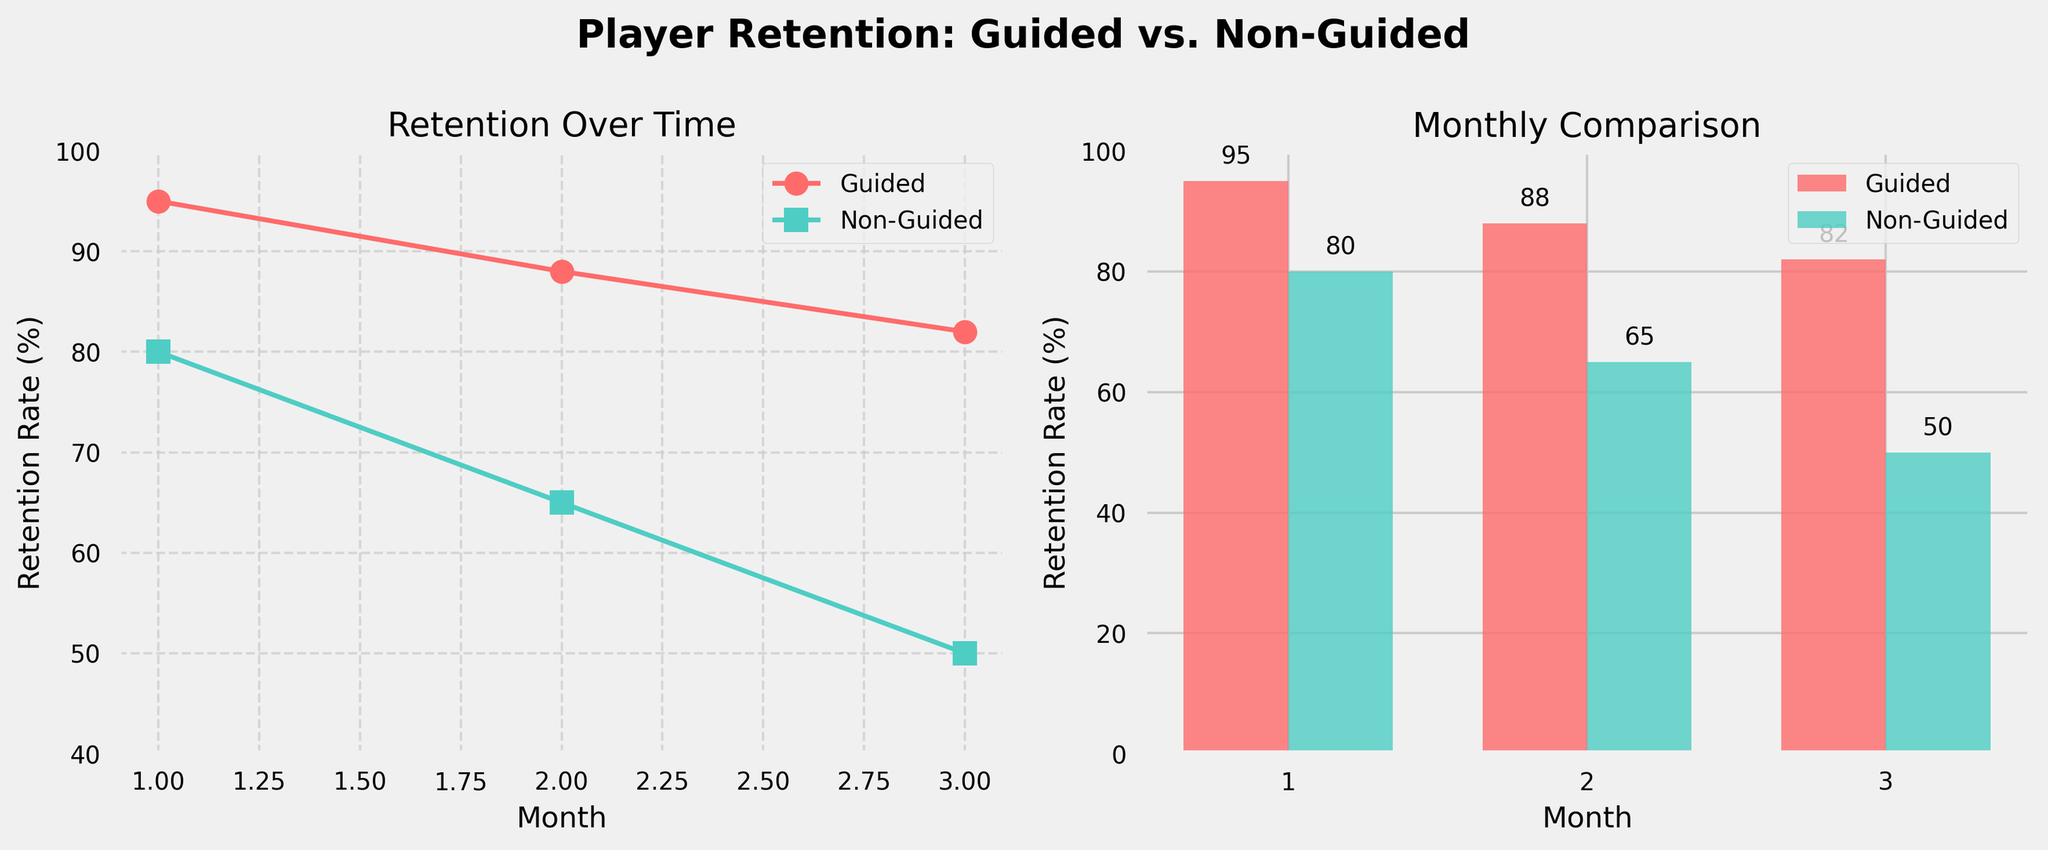What is the retention rate for guided players in the first month? Refer to the line plot or the bar chart, where the first-month retention rate for guided players is depicted.
Answer: 95% What is the title of the entire figure? The title is located at the top of the figure.
Answer: Player Retention: Guided vs. Non-Guided Which player group has a higher retention rate in the third month? Compare the retention rates for guided and non-guided players in the third month from either the line plot or bar chart.
Answer: Guided players By how much does the retention rate drop for non-guided players from the first to the second month? Subtract the retention rate in the second month from the retention rate in the first month for non-guided players (80% - 65%).
Answer: 15% What is the overall trend of retention rates for both guided and non-guided players over the three months? Examine the slopes of the lines in the line plot which show that retention rates decline for both groups over the three months.
Answer: Declining What are the colors used to represent guided and non-guided players in the plots? Identify the colors on the legends of the subplots. Guided players are represented with one color and non-guided players with another.
Answer: Red for guided, teal for non-guided How much higher is the retention rate for guided players compared to non-guided players in the second month? Subtract the non-guided players' retention rate from the guided players' retention rate in the second month (88% - 65%).
Answer: 23% By what percentage do both guided and non-guided player retention rates decrease from the second to the third month on average? Calculate the differences for guided (88% to 82%) and non-guided (65% to 50%). Then take the average: [(6 + 15) / 2].
Answer: 10.5% In which month is the difference in retention rates between guided and non-guided players the largest? Observe the differences in retention rates for each month and identify the largest one. The differences are 15% in the first month, 23% in the second month, and 32% in the third month.
Answer: Third month What does the height of the bars represent in the second subplot (Monthly Comparison)? Look at the bars' y-axis label to understand what's being represented.
Answer: Retention Rate (%) 